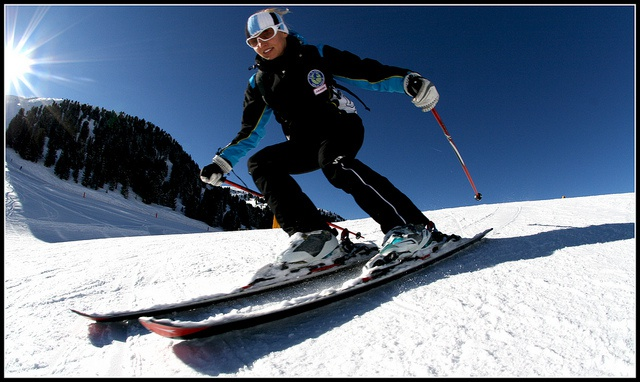Describe the objects in this image and their specific colors. I can see people in black, darkgray, navy, and gray tones and skis in black, white, gray, and darkgray tones in this image. 